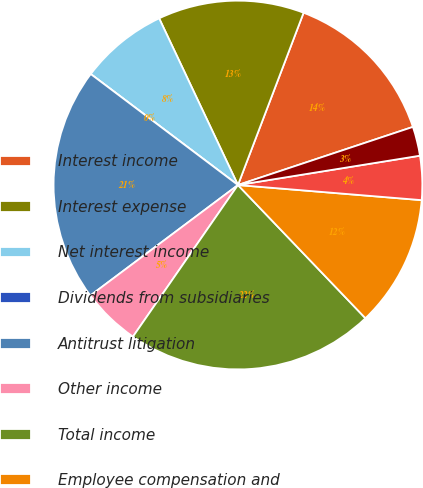Convert chart to OTSL. <chart><loc_0><loc_0><loc_500><loc_500><pie_chart><fcel>Interest income<fcel>Interest expense<fcel>Net interest income<fcel>Dividends from subsidiaries<fcel>Antitrust litigation<fcel>Other income<fcel>Total income<fcel>Employee compensation and<fcel>Marketing and business<fcel>Information processing and<nl><fcel>14.1%<fcel>12.82%<fcel>7.69%<fcel>0.0%<fcel>20.51%<fcel>5.13%<fcel>21.79%<fcel>11.54%<fcel>3.85%<fcel>2.56%<nl></chart> 